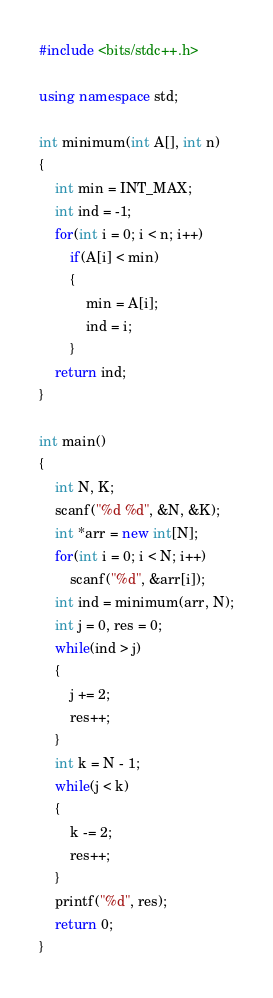Convert code to text. <code><loc_0><loc_0><loc_500><loc_500><_C++_>#include <bits/stdc++.h>

using namespace std;

int minimum(int A[], int n)
{
	int min = INT_MAX;
	int ind = -1;
	for(int i = 0; i < n; i++)
		if(A[i] < min)
		{
			min = A[i];
			ind = i;
		}
	return ind;
}

int main()
{
	int N, K;
	scanf("%d %d", &N, &K);
	int *arr = new int[N];
	for(int i = 0; i < N; i++)
		scanf("%d", &arr[i]);
	int ind = minimum(arr, N);
	int j = 0, res = 0;
	while(ind > j)
	{
		j += 2;
		res++;
	}
	int k = N - 1;
	while(j < k)
	{
		k -= 2;
		res++;
	}
	printf("%d", res);
	return 0;
}</code> 